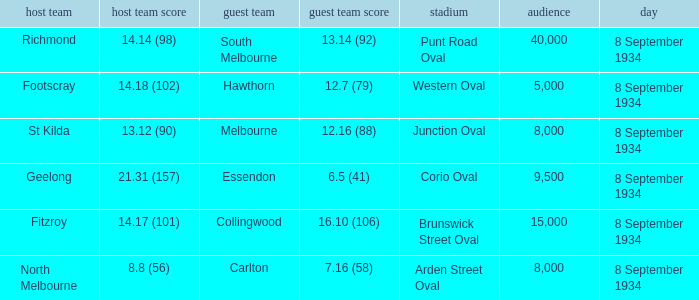When Melbourne was the Away team, what was their score? 12.16 (88). 